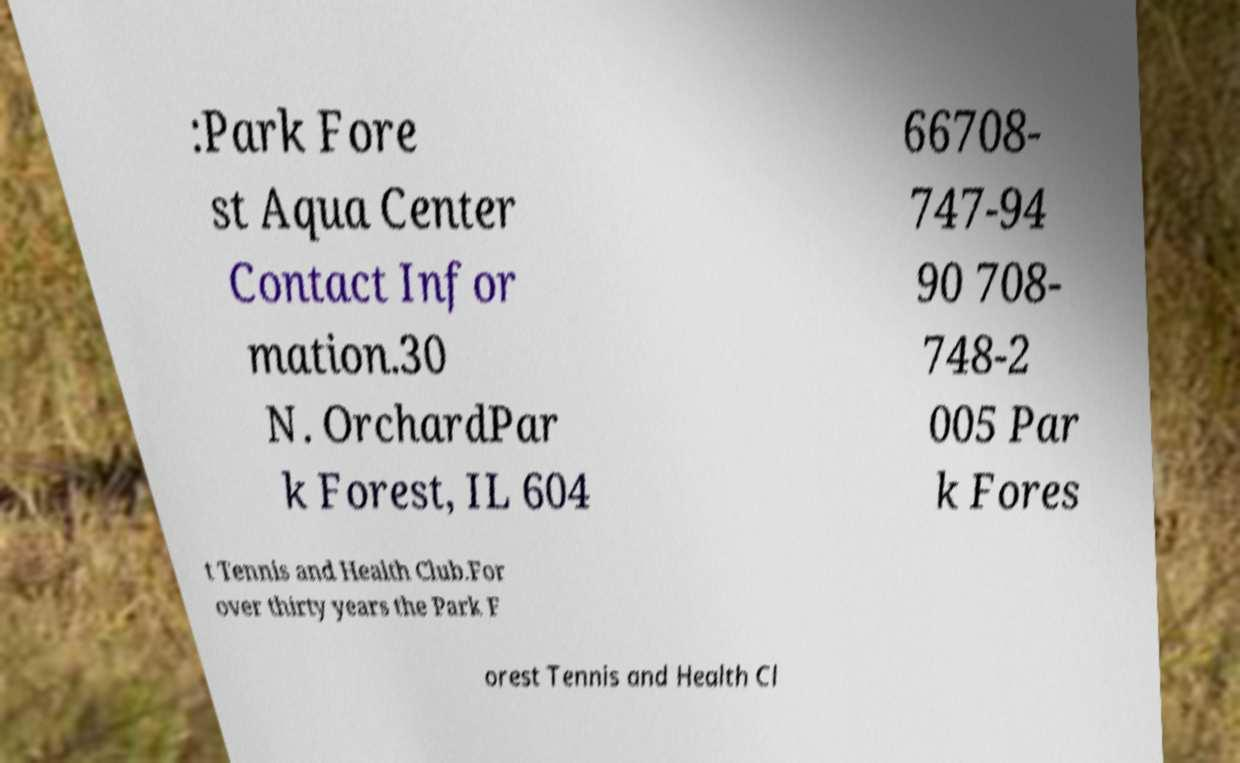Could you extract and type out the text from this image? :Park Fore st Aqua Center Contact Infor mation.30 N. OrchardPar k Forest, IL 604 66708- 747-94 90 708- 748-2 005 Par k Fores t Tennis and Health Club.For over thirty years the Park F orest Tennis and Health Cl 